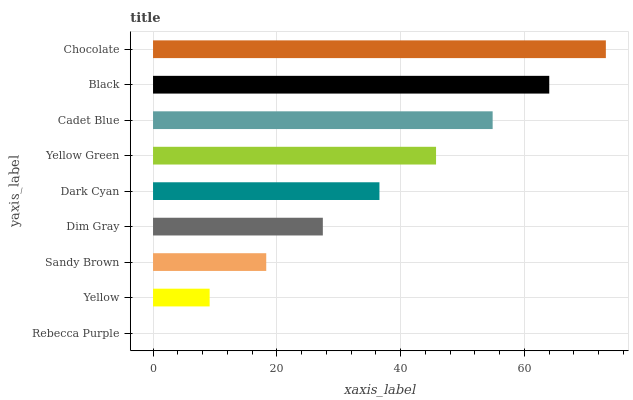Is Rebecca Purple the minimum?
Answer yes or no. Yes. Is Chocolate the maximum?
Answer yes or no. Yes. Is Yellow the minimum?
Answer yes or no. No. Is Yellow the maximum?
Answer yes or no. No. Is Yellow greater than Rebecca Purple?
Answer yes or no. Yes. Is Rebecca Purple less than Yellow?
Answer yes or no. Yes. Is Rebecca Purple greater than Yellow?
Answer yes or no. No. Is Yellow less than Rebecca Purple?
Answer yes or no. No. Is Dark Cyan the high median?
Answer yes or no. Yes. Is Dark Cyan the low median?
Answer yes or no. Yes. Is Cadet Blue the high median?
Answer yes or no. No. Is Yellow the low median?
Answer yes or no. No. 